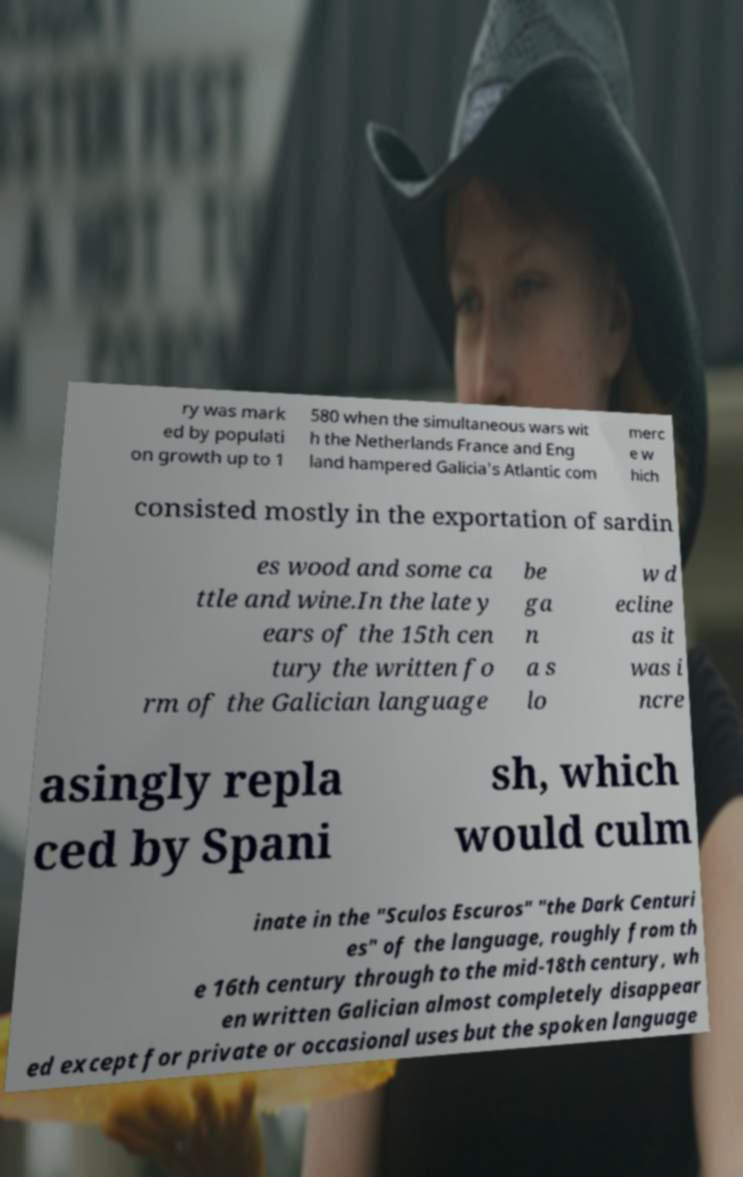Could you extract and type out the text from this image? ry was mark ed by populati on growth up to 1 580 when the simultaneous wars wit h the Netherlands France and Eng land hampered Galicia's Atlantic com merc e w hich consisted mostly in the exportation of sardin es wood and some ca ttle and wine.In the late y ears of the 15th cen tury the written fo rm of the Galician language be ga n a s lo w d ecline as it was i ncre asingly repla ced by Spani sh, which would culm inate in the "Sculos Escuros" "the Dark Centuri es" of the language, roughly from th e 16th century through to the mid-18th century, wh en written Galician almost completely disappear ed except for private or occasional uses but the spoken language 